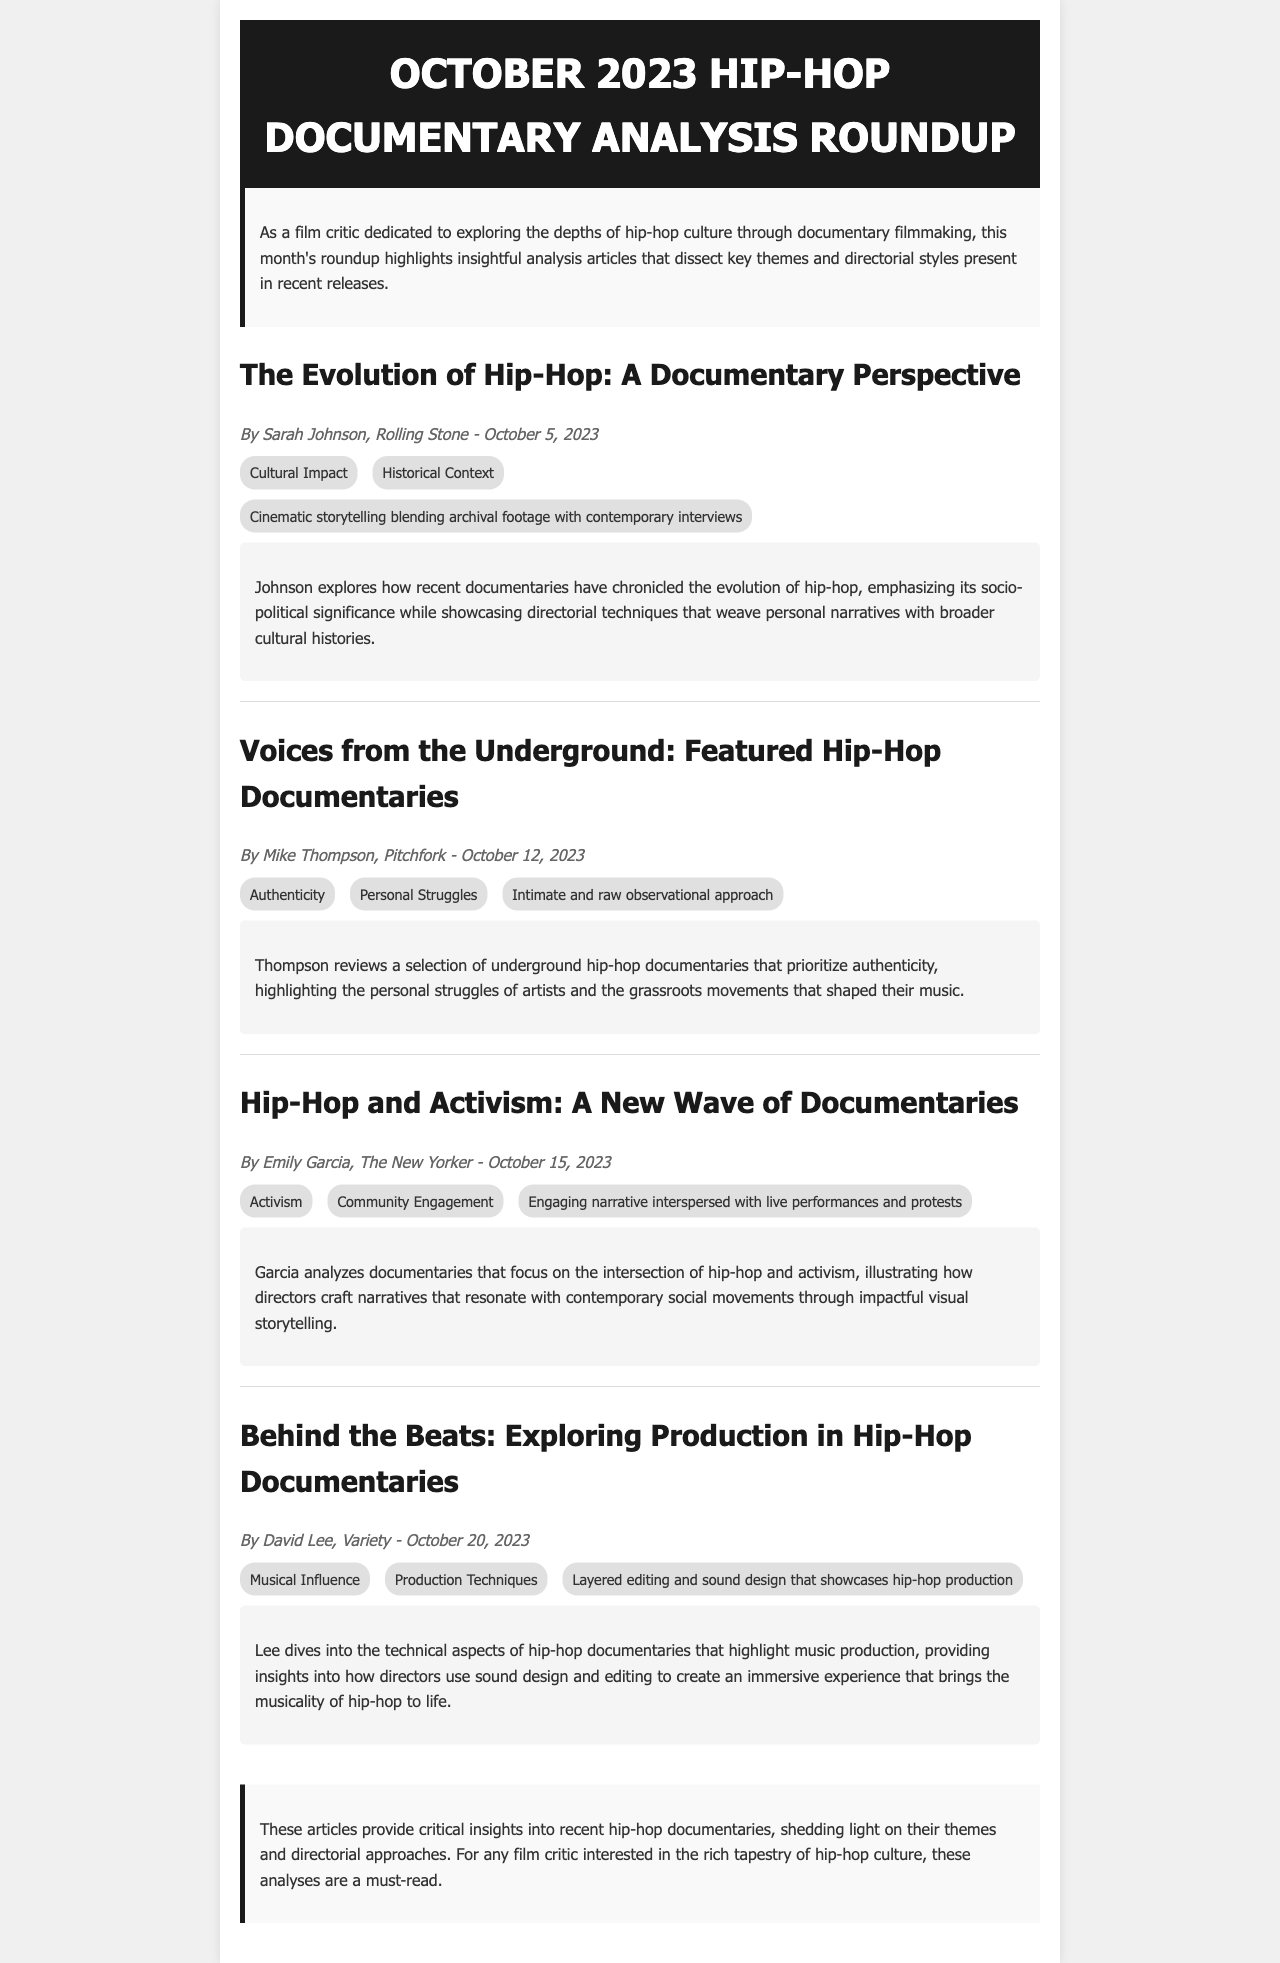What is the title of the document? The title of the document is presented in the header section, highlighting the content it covers.
Answer: October 2023 Hip-Hop Documentary Analysis Roundup Who wrote the article "Voices from the Underground: Featured Hip-Hop Documentaries"? The author of this article is mentioned in the meta section under the article title, providing attribution to the writer.
Answer: Mike Thompson What date was "Hip-Hop and Activism: A New Wave of Documentaries" published? The publication date for this article is included in the meta section, specifying when it was released.
Answer: October 15, 2023 Which publication featured "Behind the Beats: Exploring Production in Hip-Hop Documentaries"? The name of the publication is listed in the meta section, indicating where the article can be found.
Answer: Variety What key theme is emphasized in all the articles? The document lists different themes under each article, showcasing the central ideas explored by the authors.
Answer: Various themes What style is highlighted in "The Evolution of Hip-Hop: A Documentary Perspective"? The style used in this article is described in terms of directorial techniques, elaborating on how the subject matter is presented.
Answer: Cinematic storytelling blending archival footage with contemporary interviews Which article discusses hip-hop's socio-political significance? The article's summary provides insights into its content focus, including aspects like historical context and social commentary.
Answer: The Evolution of Hip-Hop: A Documentary Perspective What is a common theme across the featured documentaries in the roundup? The summaries indicate the social issues addressed in the documentaries, reflecting the broader themes present in contemporary hip-hop.
Answer: Activism and authenticity Who is the author of the article that explores musical production in hip-hop documentaries? The author's name is found in the meta section of the article, reflecting who provided the analysis.
Answer: David Lee 